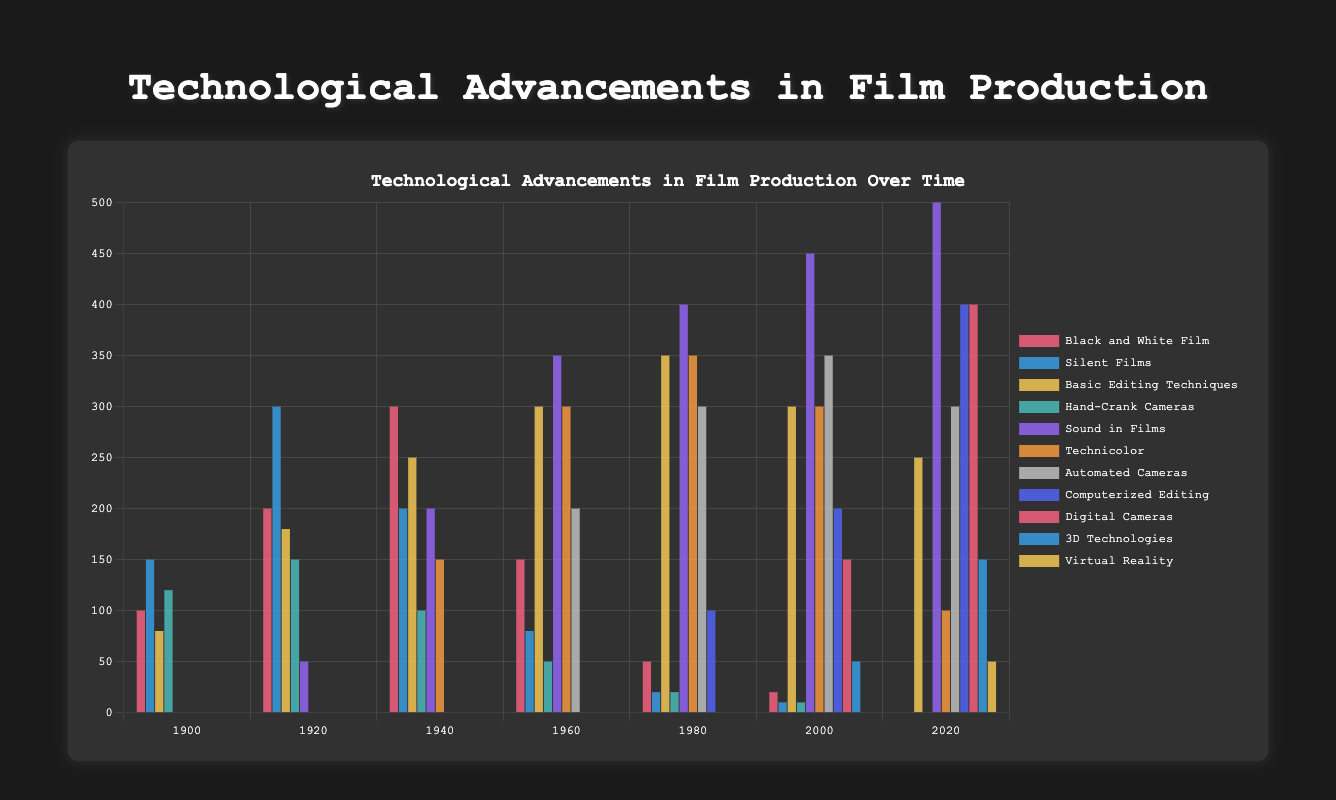What is the trend of "Black and White Film" usage from 1900 to 2020? From the bar chart, "Black and White Film" usage starts at 100 in 1900, peaks at 300 in 1940, and gradually declines to 0 by 2020. The trend shows an initial increase, a peak around mid-century, and then a drop to zero.
Answer: Declining In which year was the usage of "Sound in Films" first introduced, and what was its value? Referring to the dataset in the bar chart, we see that "Sound in Films" first appears in 1920 with a value of 50.
Answer: 1920, 50 Compare the usage of "Computerized Editing" between 1980 and 2020, and state the difference. In 1980, "Computerized Editing" has a value of 100. By 2020, this value increases to 400. The difference is calculated as 400 - 100 = 300.
Answer: 300 Which technology had the highest usage in 2020, and what was its value? Observing the bars for 2020, "Sound in Films" stands the tallest with a value of 500.
Answer: Sound in Films, 500 How did the introduction of "3D Technologies" compare to "Virtual Reality" in terms of the years they appeared? "3D Technologies" was introduced in 2000, while "Virtual Reality" made its appearance in 2020. Thus, "3D Technologies" appeared 20 years before "Virtual Reality".
Answer: 20 years difference Which year saw the peak usage of "Hand-Crank Cameras"? What was the value at that peak? The data show that "Hand-Crank Cameras" reached their maximum usage in 1920 with a value of 150.
Answer: 1920, 150 How did "Technicolor" usage change from 1940 to 2020? "Technicolor" started at 150 in 1940, increased to 300 in 1960, peaked at 350 in 1980, and then declined to 100 by 2020.
Answer: Initial increase, peak in 1980, decline by 2020 What is the total usage of "Automated Cameras" over all the years presented in the chart? Summing the values from the bar chart: 0 (1900) + 0 (1920) + 0 (1940) + 200 (1960) + 300 (1980) + 350 (2000) + 300 (2020) = 1150.
Answer: 1150 By how much did the usage of "Sound in Films" increase from 1920 to 2020? "Sound in Films" in 1920 was 50, and it increased to 500 by 2020. The increase is calculated as 500 - 50 = 450.
Answer: 450 What is the predominant color used for the "Virtual Reality" bar in the chart, and what does its height represent? The color used for "Virtual Reality" is broadly described as yellowish ("rgba(255, 206, 86, 0.8)"). The bar is 50 units tall, representing its usage value of 50 in 2020.
Answer: Yellowish, 50 